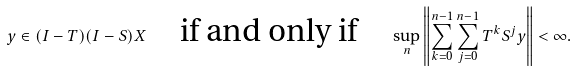<formula> <loc_0><loc_0><loc_500><loc_500>y \in ( I - T ) ( I - S ) X \quad \text {if and only if} \quad \sup _ { n } \left \| \sum _ { k = 0 } ^ { n - 1 } \sum _ { j = 0 } ^ { n - 1 } T ^ { k } S ^ { j } y \right \| < \infty .</formula> 